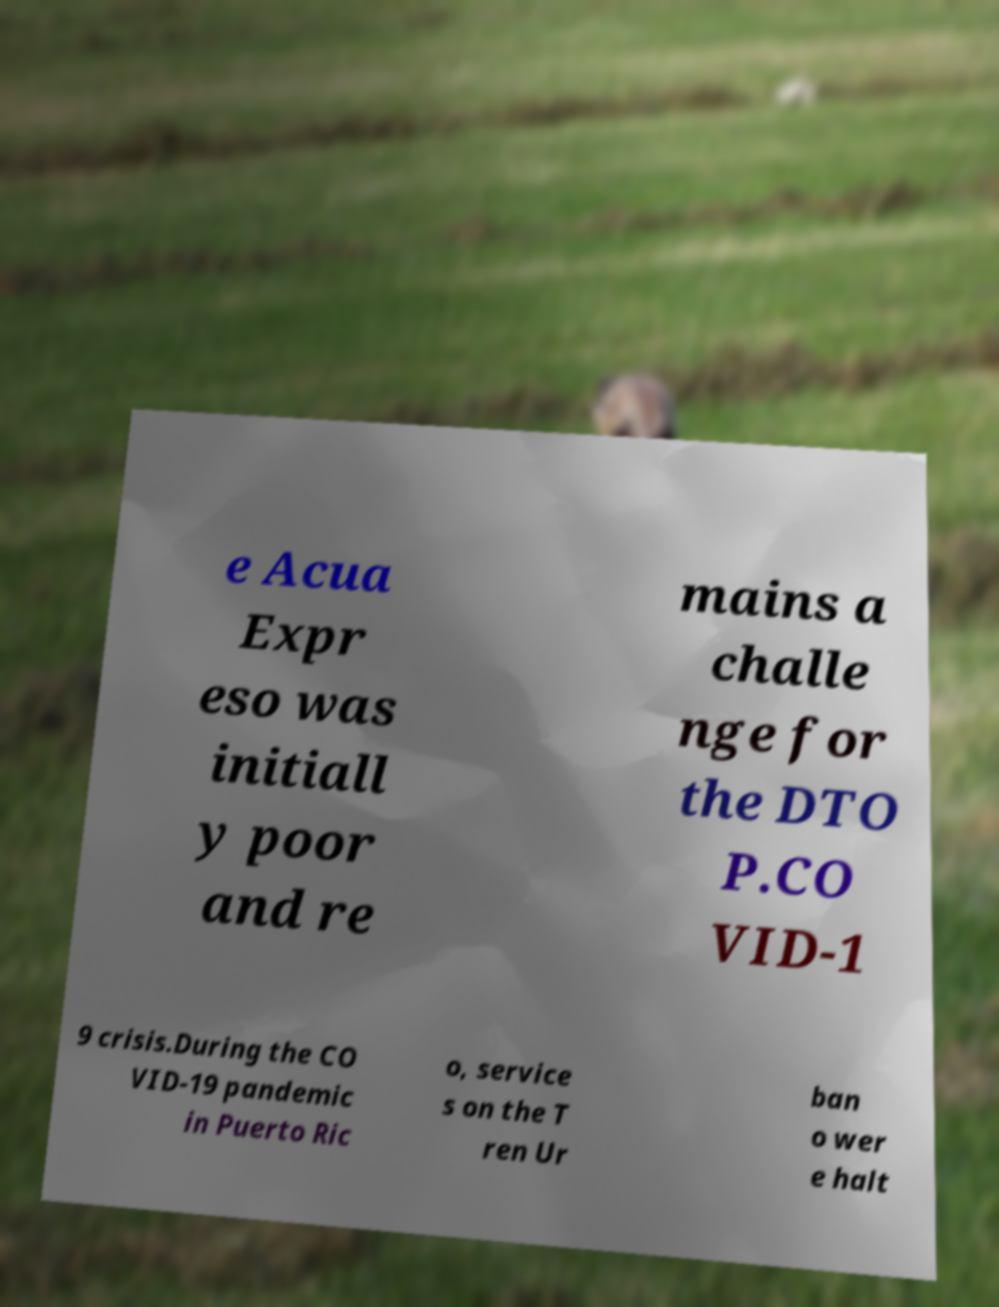Please identify and transcribe the text found in this image. e Acua Expr eso was initiall y poor and re mains a challe nge for the DTO P.CO VID-1 9 crisis.During the CO VID-19 pandemic in Puerto Ric o, service s on the T ren Ur ban o wer e halt 